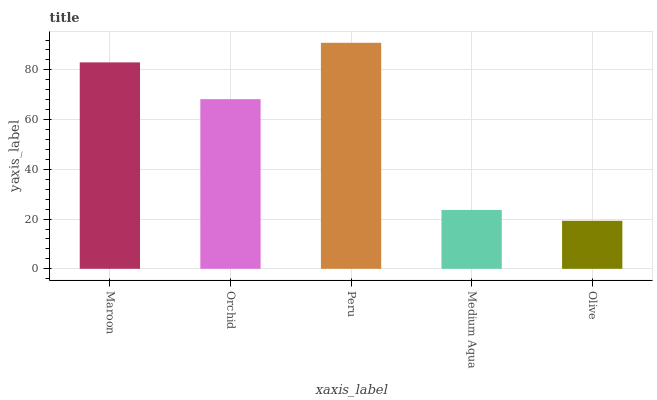Is Olive the minimum?
Answer yes or no. Yes. Is Peru the maximum?
Answer yes or no. Yes. Is Orchid the minimum?
Answer yes or no. No. Is Orchid the maximum?
Answer yes or no. No. Is Maroon greater than Orchid?
Answer yes or no. Yes. Is Orchid less than Maroon?
Answer yes or no. Yes. Is Orchid greater than Maroon?
Answer yes or no. No. Is Maroon less than Orchid?
Answer yes or no. No. Is Orchid the high median?
Answer yes or no. Yes. Is Orchid the low median?
Answer yes or no. Yes. Is Maroon the high median?
Answer yes or no. No. Is Medium Aqua the low median?
Answer yes or no. No. 